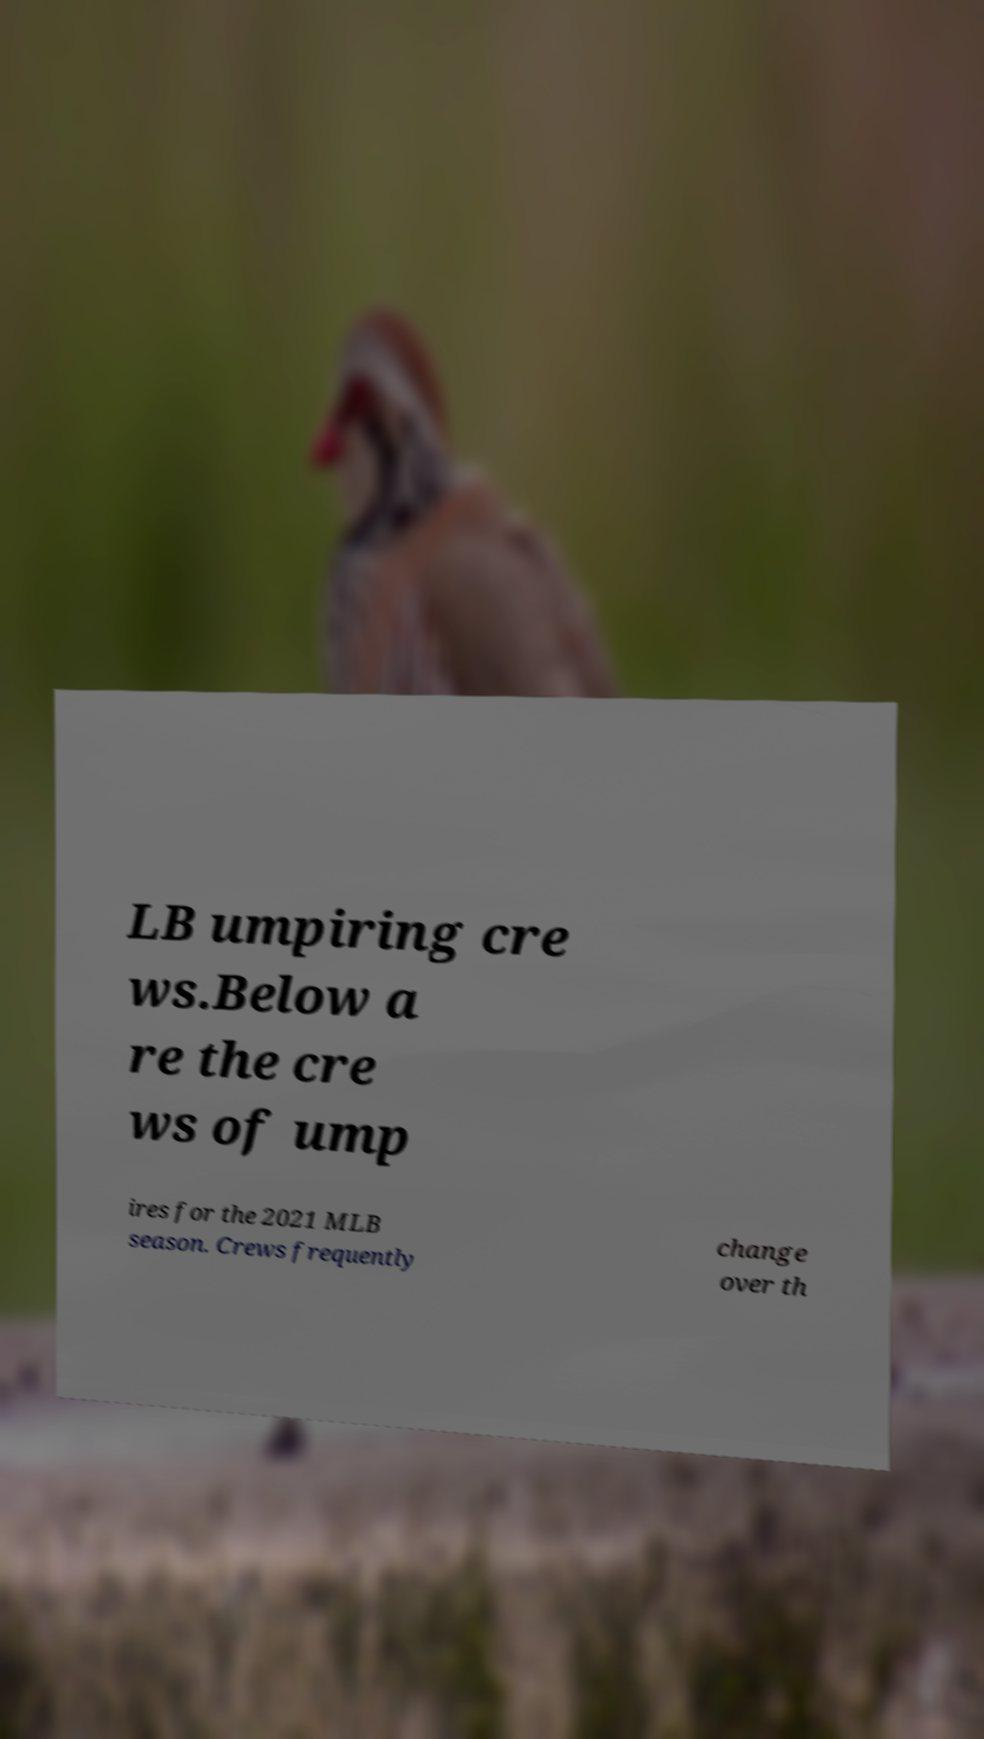Please identify and transcribe the text found in this image. LB umpiring cre ws.Below a re the cre ws of ump ires for the 2021 MLB season. Crews frequently change over th 